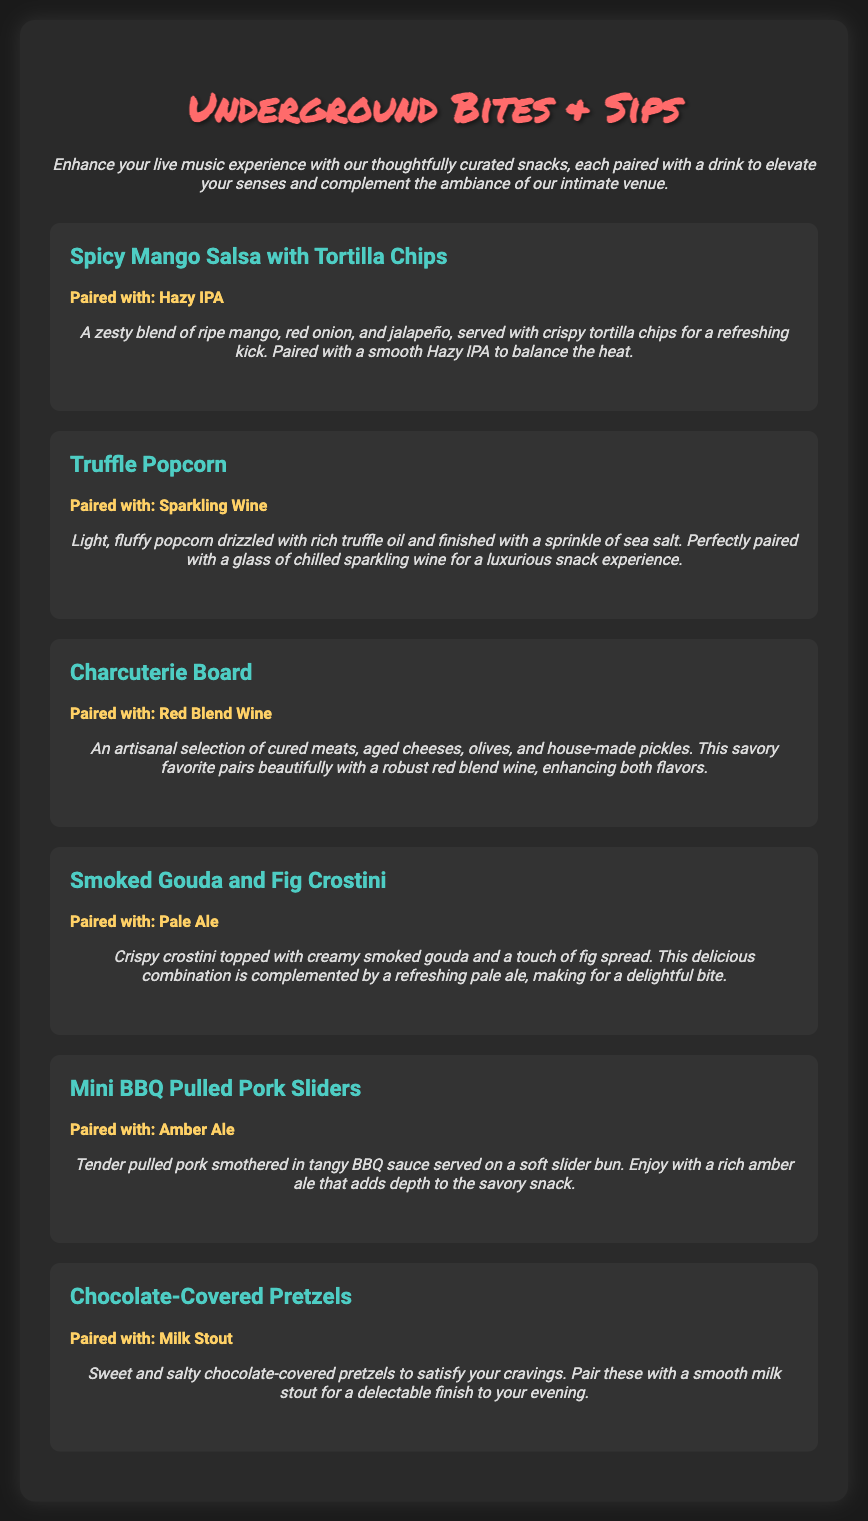what is the name of the venue? The name of the venue is mentioned in the title at the top of the document.
Answer: Underground Bites & Sips how many snack offerings are listed? The document lists a total of six distinct snack offerings.
Answer: 6 which drink is paired with the Charcuterie Board? The pairing information for the Charcuterie Board is provided in the description of the menu item.
Answer: Red Blend Wine what is the main ingredient in the Spicy Mango Salsa? The document describes the ingredients of the Spicy Mango Salsa, highlighting the key component.
Answer: Mango what is the suggested pairing for the Mini BBQ Pulled Pork Sliders? The pairing information for the Mini BBQ Pulled Pork Sliders is included in the menu item details.
Answer: Amber Ale which snack is paired with Sparkling Wine? The pairing for each snack is specified, with one directly paired with Sparkling Wine.
Answer: Truffle Popcorn which flavor is featured in the Chocolate-Covered Pretzels? The flavor profile of the Chocolate-Covered Pretzels is detailed in the menu description.
Answer: Sweet and salty how does the description enhance the live music experience? The introductory description emphasizes how snacks elevate the ambiance and enjoyment of live music events.
Answer: Enhance your live music experience what ingredient is used in the Smoked Gouda and Fig Crostini? The main ingredients of the Smoked Gouda and Fig Crostini are specifically mentioned.
Answer: Smoked Gouda 